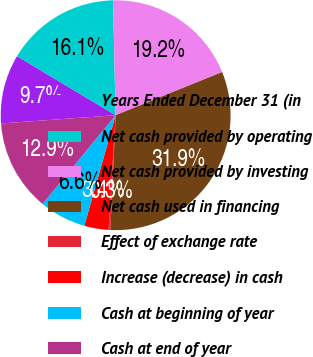Convert chart. <chart><loc_0><loc_0><loc_500><loc_500><pie_chart><fcel>Years Ended December 31 (in<fcel>Net cash provided by operating<fcel>Net cash provided by investing<fcel>Net cash used in financing<fcel>Effect of exchange rate<fcel>Increase (decrease) in cash<fcel>Cash at beginning of year<fcel>Cash at end of year<nl><fcel>9.73%<fcel>16.05%<fcel>19.23%<fcel>31.86%<fcel>0.25%<fcel>3.41%<fcel>6.57%<fcel>12.89%<nl></chart> 